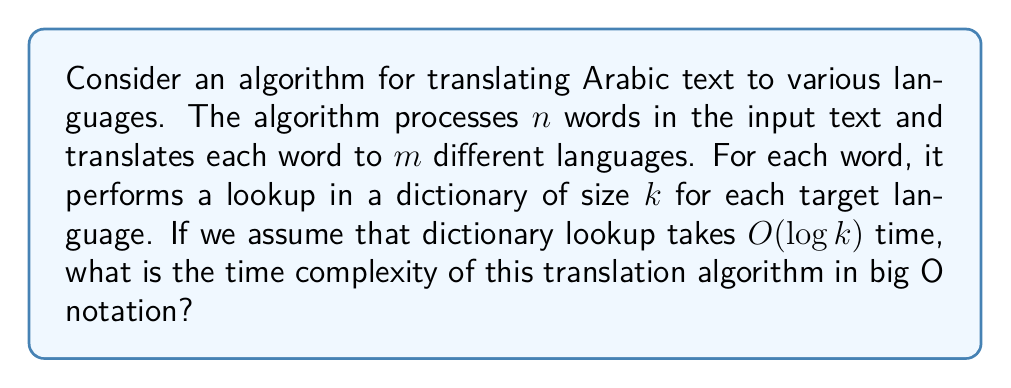Give your solution to this math problem. To analyze the time complexity of this algorithm, let's break it down step by step:

1. The algorithm processes $n$ words in the input text.

2. For each word, it translates to $m$ different languages.

3. For each language translation, it performs a dictionary lookup of size $k$.

4. Each dictionary lookup takes $O(\log k)$ time.

Therefore, we can express the time complexity as follows:

- For each word: $m$ translations
- For each translation: $O(\log k)$ time for dictionary lookup
- Total words: $n$

This gives us the following expression:

$$ n \cdot m \cdot O(\log k) $$

Simplifying this expression:

$$ O(n \cdot m \cdot \log k) $$

This represents the overall time complexity of the algorithm.

In the context of Arabic text translation, $n$ would represent the number of words in the Arabic text, $m$ would be the number of target languages for translation, and $k$ would be the size of the translation dictionary for each language.
Answer: $O(n \cdot m \cdot \log k)$ 